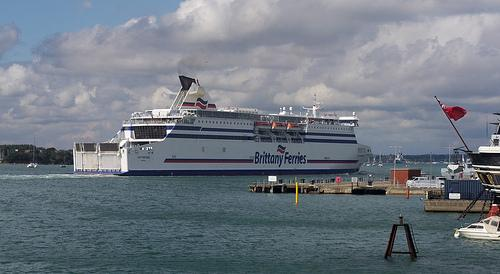Mention the prominent features you see within the image. A large boat in the water, a wooden pier, a small boat, a red flag on a pole, blue sky with clouds, calm water, and a shipping container. Can you give a summary of the scenic beauty that's captured in the image? A tranquil waterscape with a big boat, a wooden pier, a flag flying gracefully, and smaller vessels surrounded by blue skies and gentle waters. What are the major elements in this picture that catch your eye? There's a big boat in the water, a wooden pier, a small boat nearby, and a red flag flying on a tall flagpole. Briefly describe the most noticeable components of the picture. The picture showcases a large boat on water, a red flag flying, and a wooden pier amidst a cloudy, serene background. Quickly identify the main object in the image and mention a few secondary objects. The main object is a large boat, and secondary objects include a red flag, a small boat, and a wooden pier. Identify the primary object in the image and what it's surrounded by. A large boat is the main focus, surrounded by water, other boats, a wooden pier, and a red flag on a pole. Write a concise description of what you see in the picture. A big boat on calm water, with a wooden pier, a small boat, and a red flag on a pole against a cloudy sky. Describe the general atmosphere of the image. It's a serene scene with calm waters, blue skies filled with clouds, and boats of various sizes moored or floating nearby. What is the main focus of the image, and what additional objects can you identify? The main focus is a large boat, with other objects including a wooden pier, smaller boats, a red flag, and a cloudy sky. What are the key elements of this picture that contribute to the overall scene? The large boat, the calm water, the wooden pier, the red flag flying in the breeze, and a cloudy sky create a peaceful atmosphere. 